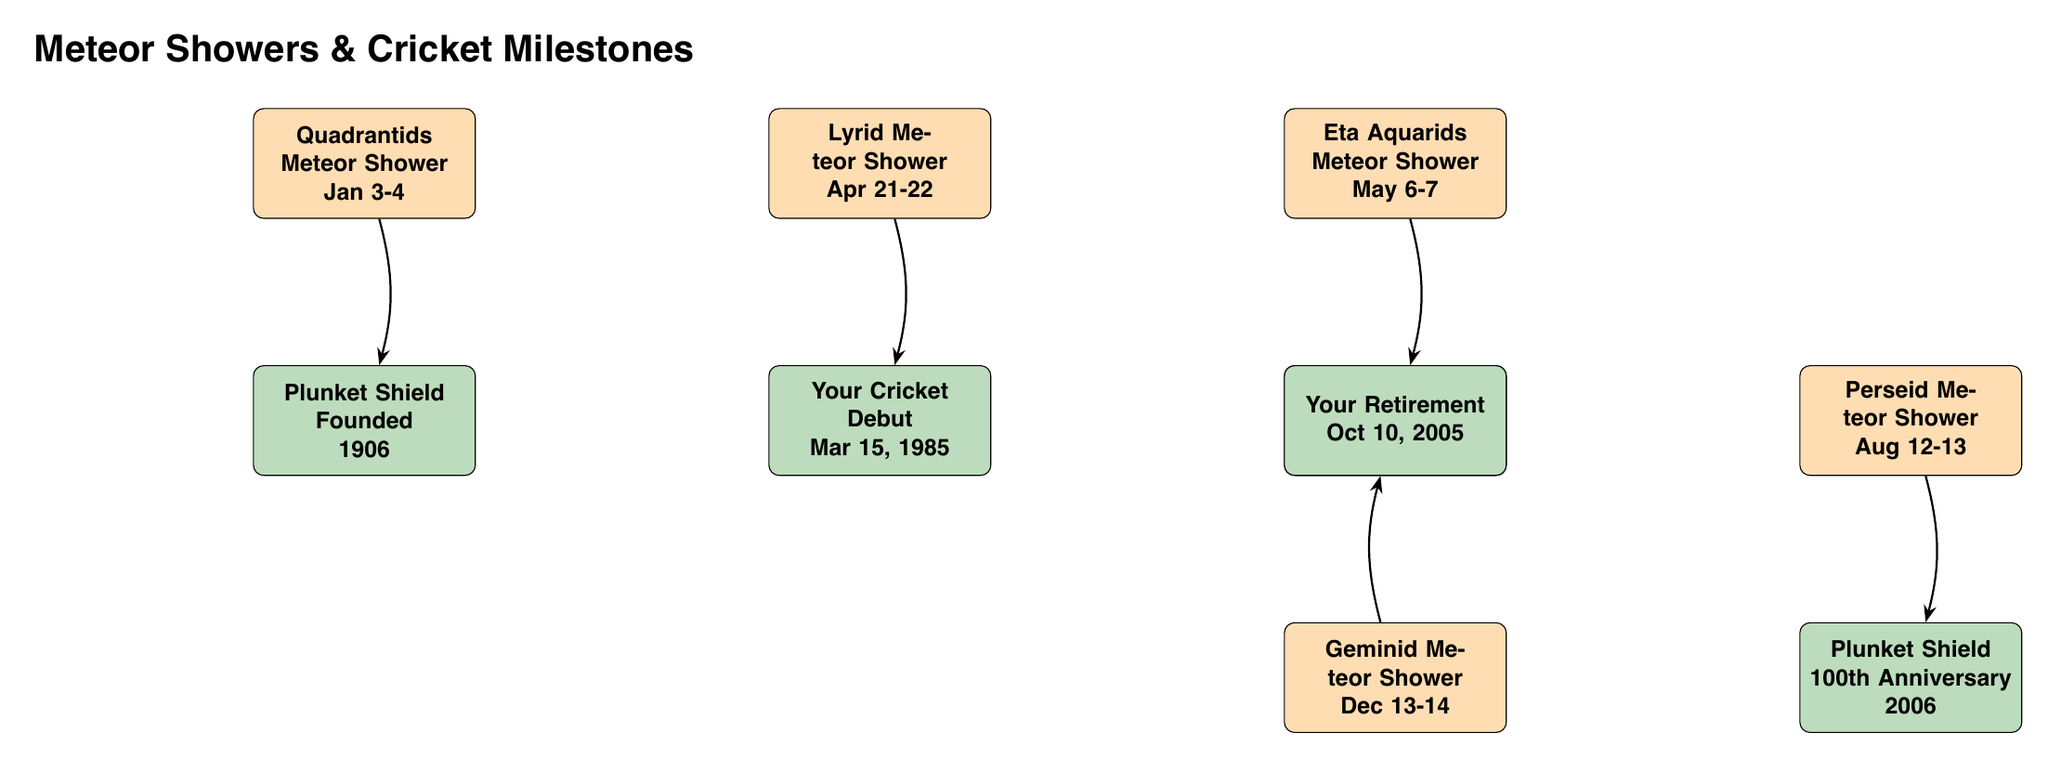What is the date of the Quadrantids Meteor Shower? The Quadrantids Meteor Shower is marked in the diagram and shows the date as Jan 3-4.
Answer: Jan 3-4 What significant cricket milestone is associated with the Lyrid Meteor Shower? The Lyrid Meteor Shower is linked to your cricket debut, which is shown below it, with the date given as Mar 15, 1985.
Answer: Your Cricket Debut What is the event linked to the Eta Aquarids Meteor Shower? Below the Eta Aquarids Meteor Shower, there is a node indicating the milestone of scoring the most runs in the cricket season, specifically mentioned as 1997-1998.
Answer: Most Runs Scored in Season Which meteor shower coincides with your retirement? The Geminid Meteor Shower is indicated to be connected to your retirement, as seen in the diagram.
Answer: Your Retirement How many major meteor showers are shown in the diagram? The diagram illustrates five meteor showers, identifiable by their respective nodes labeled Quadrantids, Lyrid, Eta Aquarids, Perseid, and Geminid.
Answer: 5 What cricket event happened in 2006? The Plunket Shield 100th Anniversary is noted in the diagram for the year 2006, directly linked to the Perseid Meteor Shower.
Answer: Plunket Shield 100th Anniversary Which event is positioned above the retirement event? The Geminid Meteor Shower is positioned directly above the retirement node, indicating the relationship between the two in the diagram.
Answer: Geminid Meteor Shower What is the earliest event shown in the diagram? The earliest event displayed is the founding of the Plunket Shield in 1906, which is linked to the Quadrantids Meteor Shower.
Answer: Plunket Shield Founded What is the relationship between the Eta Aquarids and the Most Runs Scored in Season? The Eta Aquarids Meteor Shower has an arrow pointing down towards the Most Runs Scored in Season, indicating a direct link or association between the two events.
Answer: Direct Link 